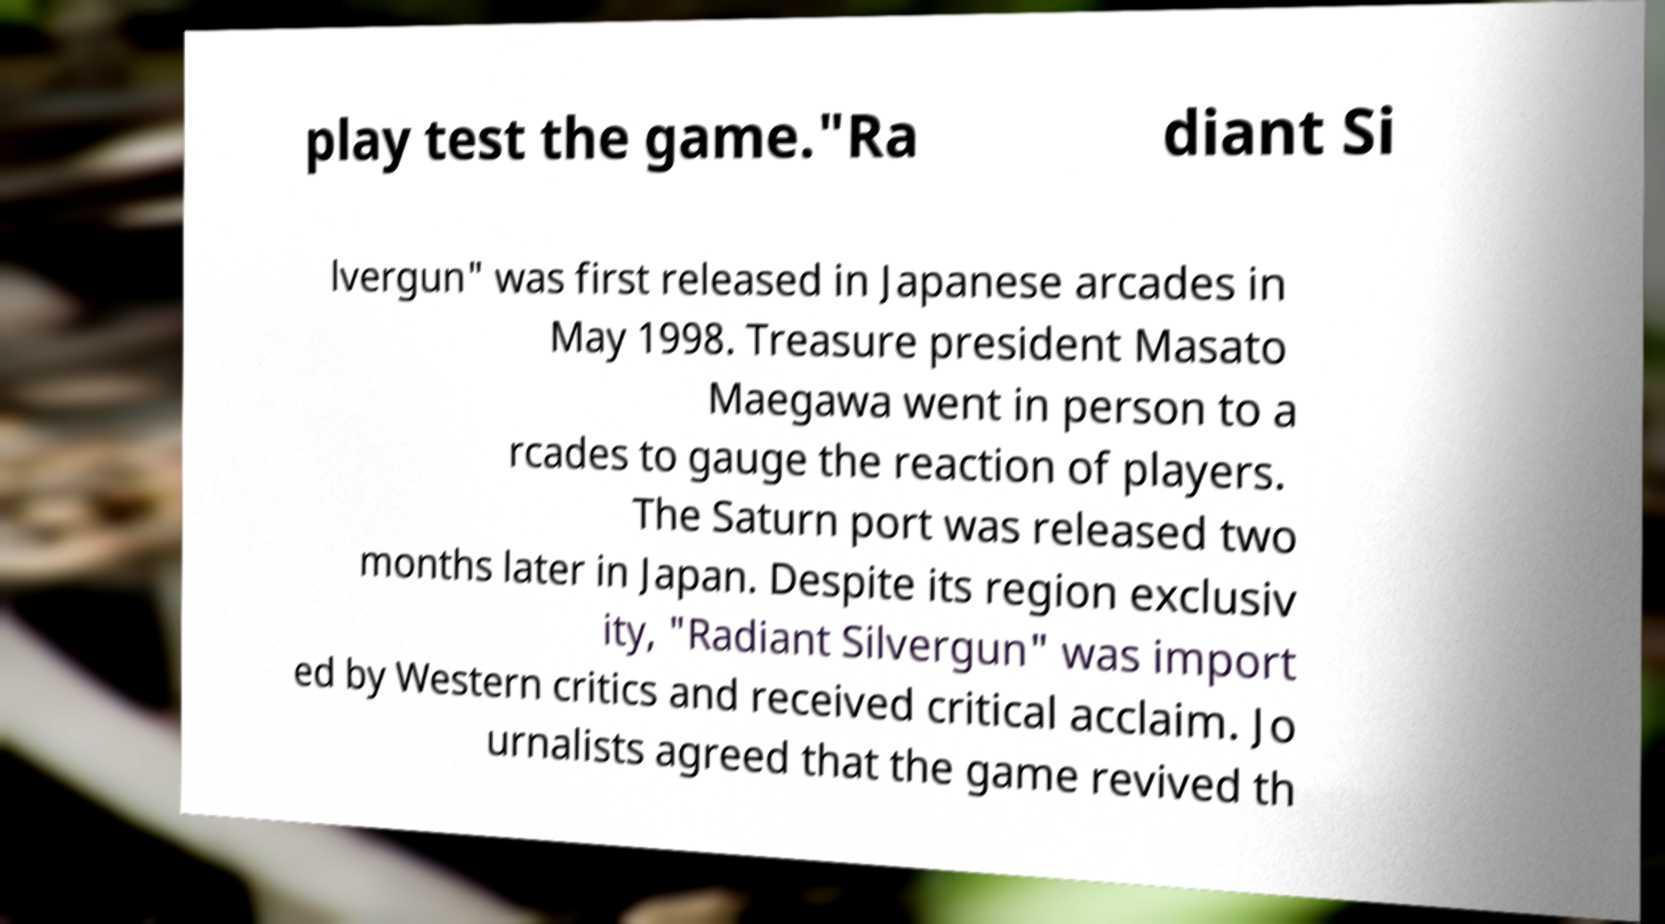I need the written content from this picture converted into text. Can you do that? play test the game."Ra diant Si lvergun" was first released in Japanese arcades in May 1998. Treasure president Masato Maegawa went in person to a rcades to gauge the reaction of players. The Saturn port was released two months later in Japan. Despite its region exclusiv ity, "Radiant Silvergun" was import ed by Western critics and received critical acclaim. Jo urnalists agreed that the game revived th 